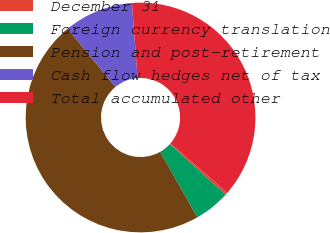<chart> <loc_0><loc_0><loc_500><loc_500><pie_chart><fcel>December 31<fcel>Foreign currency translation<fcel>Pension and post-retirement<fcel>Cash flow hedges net of tax<fcel>Total accumulated other<nl><fcel>0.35%<fcel>5.04%<fcel>47.28%<fcel>9.74%<fcel>37.58%<nl></chart> 